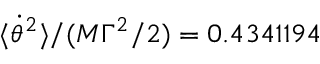Convert formula to latex. <formula><loc_0><loc_0><loc_500><loc_500>\langle \dot { \theta } ^ { 2 } \rangle / ( M \Gamma ^ { 2 } / 2 ) = 0 . 4 3 4 1 1 9 4</formula> 